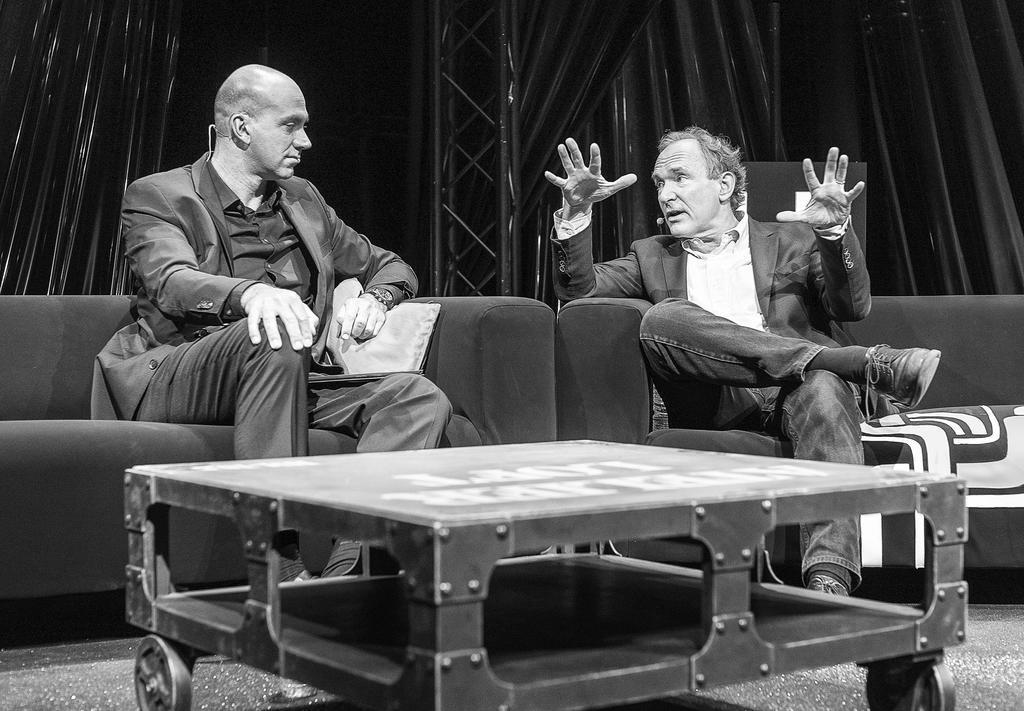Can you describe this image briefly? In the above picture there are two men sitting on the sofa talking to each other. The person on the right side of the picture is expressing something with his hands and the other person seems like seeing to the person who is talking. The whole picture is in black and white color. There is centre piece table in front of those persons and in the back ground of the picture there is a curtain and the poles and a big pole. These persons are wearing suit blazer suit with the shoes on them. 